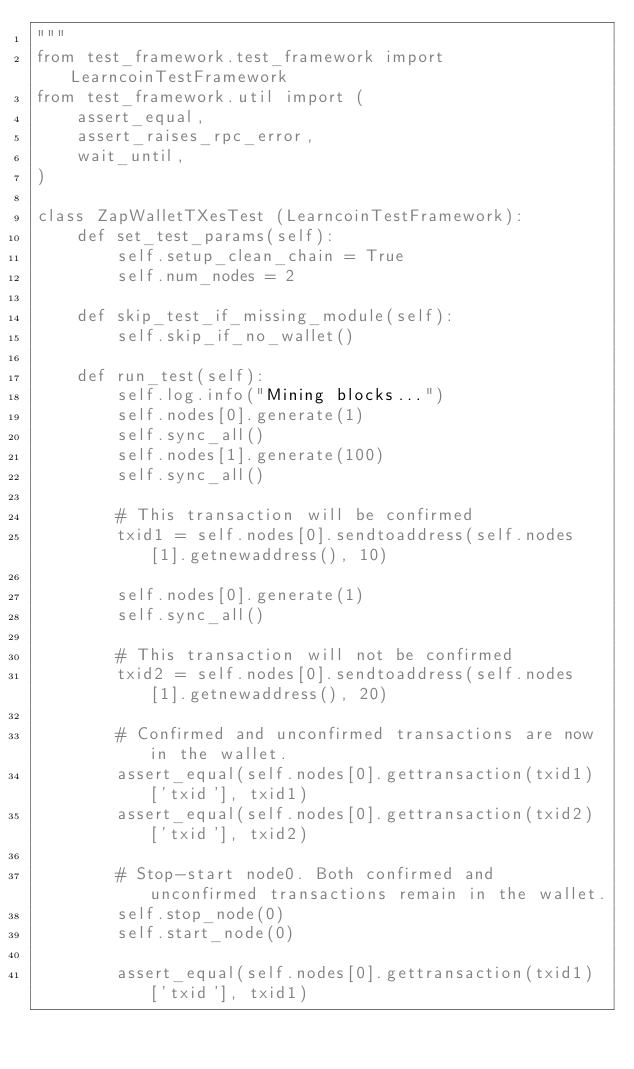<code> <loc_0><loc_0><loc_500><loc_500><_Python_>"""
from test_framework.test_framework import LearncoinTestFramework
from test_framework.util import (
    assert_equal,
    assert_raises_rpc_error,
    wait_until,
)

class ZapWalletTXesTest (LearncoinTestFramework):
    def set_test_params(self):
        self.setup_clean_chain = True
        self.num_nodes = 2

    def skip_test_if_missing_module(self):
        self.skip_if_no_wallet()

    def run_test(self):
        self.log.info("Mining blocks...")
        self.nodes[0].generate(1)
        self.sync_all()
        self.nodes[1].generate(100)
        self.sync_all()

        # This transaction will be confirmed
        txid1 = self.nodes[0].sendtoaddress(self.nodes[1].getnewaddress(), 10)

        self.nodes[0].generate(1)
        self.sync_all()

        # This transaction will not be confirmed
        txid2 = self.nodes[0].sendtoaddress(self.nodes[1].getnewaddress(), 20)

        # Confirmed and unconfirmed transactions are now in the wallet.
        assert_equal(self.nodes[0].gettransaction(txid1)['txid'], txid1)
        assert_equal(self.nodes[0].gettransaction(txid2)['txid'], txid2)

        # Stop-start node0. Both confirmed and unconfirmed transactions remain in the wallet.
        self.stop_node(0)
        self.start_node(0)

        assert_equal(self.nodes[0].gettransaction(txid1)['txid'], txid1)</code> 